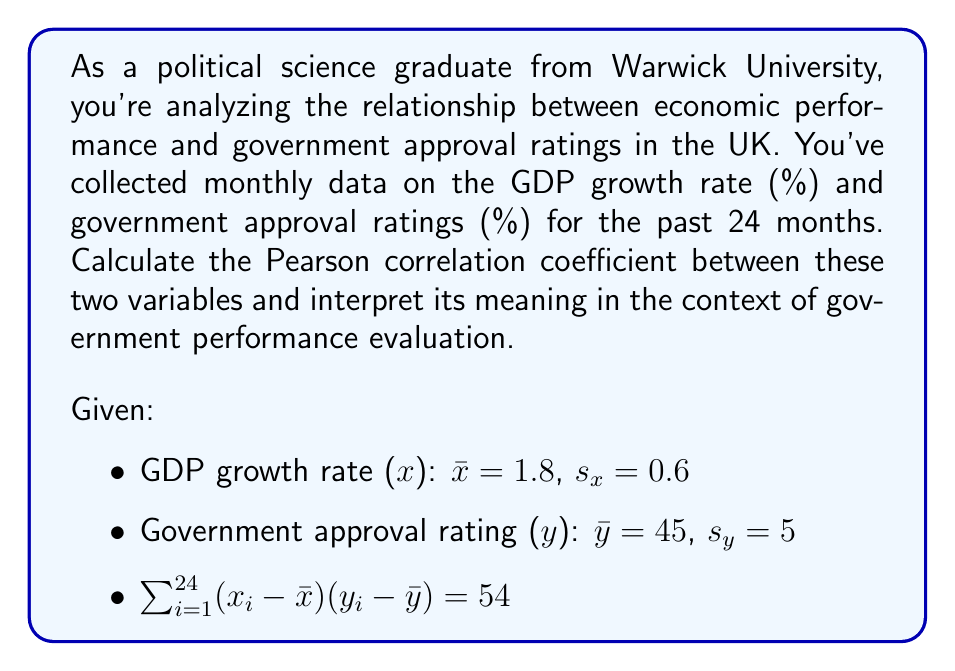What is the answer to this math problem? To calculate the Pearson correlation coefficient (r) between GDP growth rate (x) and government approval ratings (y), we'll use the formula:

$$r = \frac{\sum_{i=1}^{n} (x_i - \bar{x})(y_i - \bar{y})}{(n-1)s_x s_y}$$

Where:
n = number of data points (24 months)
$\bar{x}$ = mean of x (GDP growth rate)
$\bar{y}$ = mean of y (government approval rating)
$s_x$ = standard deviation of x
$s_y$ = standard deviation of y

We're given:
$\bar{x} = 1.8$
$\bar{y} = 45$
$s_x = 0.6$
$s_y = 5$
$\sum_{i=1}^{24} (x_i - \bar{x})(y_i - \bar{y}) = 54$

Plugging these values into the formula:

$$r = \frac{54}{(24-1)(0.6)(5)}$$

$$r = \frac{54}{69}$$

$$r \approx 0.7826$$

Interpretation:
The Pearson correlation coefficient ranges from -1 to 1, where:
- 1 indicates a perfect positive correlation
- -1 indicates a perfect negative correlation
- 0 indicates no linear correlation

A value of 0.7826 suggests a strong positive correlation between GDP growth rate and government approval ratings. This means that as the GDP growth rate increases, government approval ratings tend to increase as well, and vice versa.

In the context of government performance evaluation, this strong positive correlation indicates that economic performance, as measured by GDP growth rate, is closely tied to public approval of the government. This suggests that the public tends to view the government more favorably when the economy is performing well, and less favorably when economic growth slows down.
Answer: The Pearson correlation coefficient between GDP growth rate and government approval ratings is approximately 0.7826, indicating a strong positive correlation. This suggests that economic performance, as measured by GDP growth rate, is closely tied to public approval of the government in the UK. 